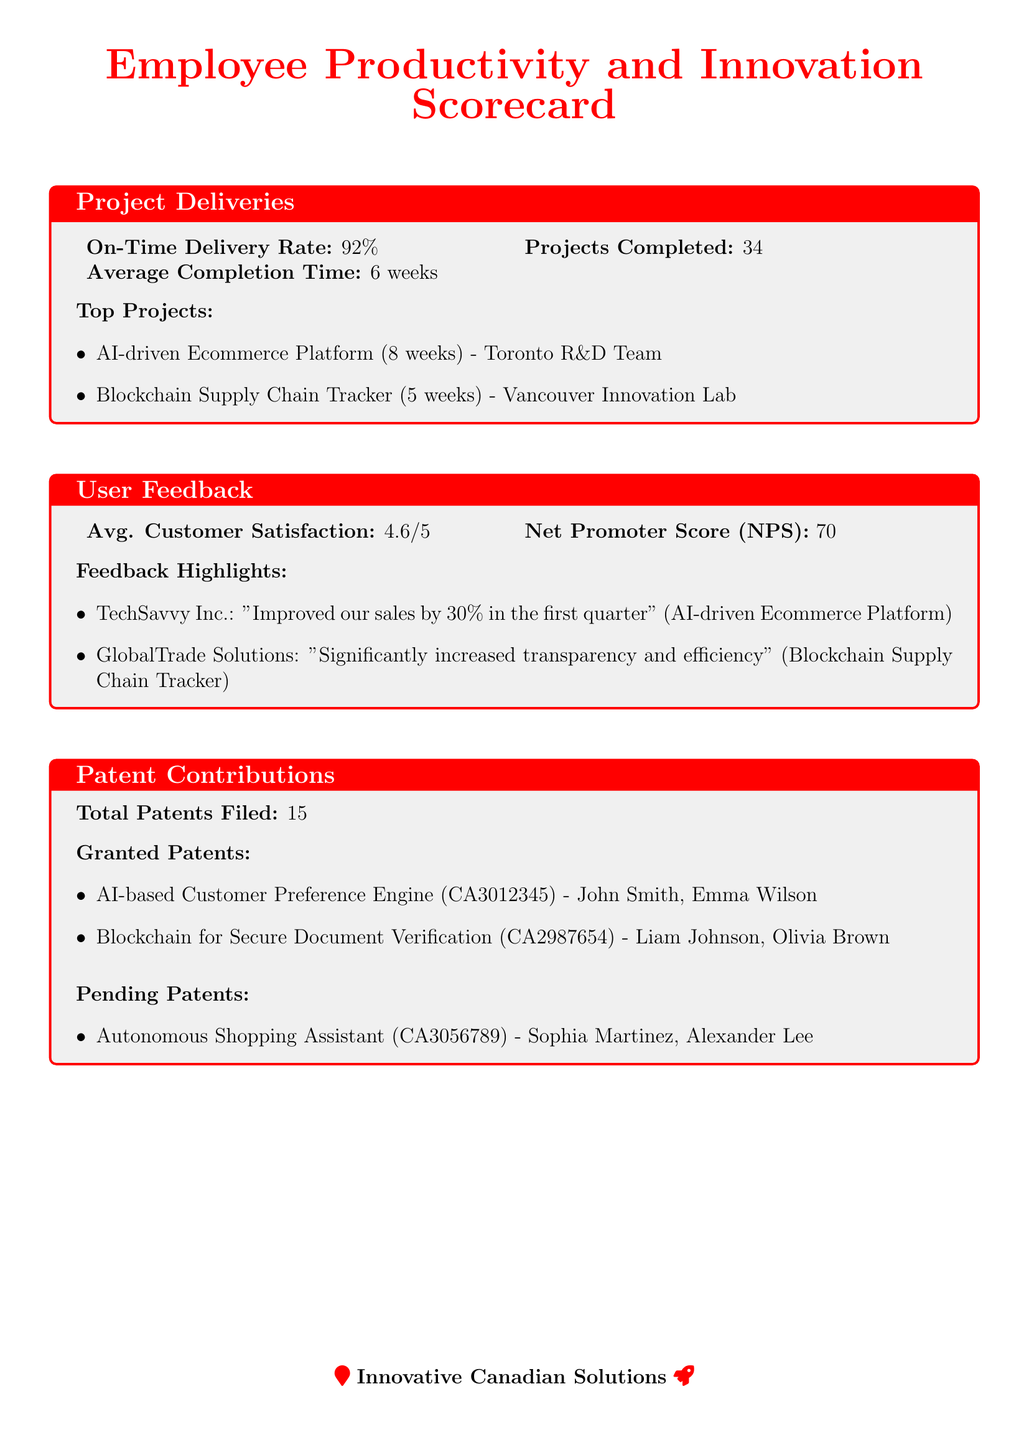What is the On-Time Delivery Rate? The On-Time Delivery Rate is a specific metric shown in the Project Deliveries section of the document, which states 92%.
Answer: 92% How many projects were completed? The document specifies a total of 34 projects completed in the Project Deliveries section.
Answer: 34 What is the Net Promoter Score (NPS)? The NPS is mentioned in the User Feedback section as a key metric, which is 70.
Answer: 70 Who are the inventors of the AI-based Customer Preference Engine? The document lists the inventors of this patent in the Patent Contributions section as John Smith and Emma Wilson.
Answer: John Smith, Emma Wilson What is the average customer satisfaction score? The average customer satisfaction score is reported in the User Feedback section, which is 4.6 out of 5.
Answer: 4.6/5 What is the average completion time for projects? The average completion time is a specific metric included in the Project Deliveries section and is noted as 6 weeks.
Answer: 6 weeks Which team completed the AI-driven Ecommerce Platform? This project is attributed to the Toronto R&D Team in the Project Deliveries section.
Answer: Toronto R&D Team How many patents are currently pending? The total number of pending patents is specified in the Patent Contributions section, which shows 1 pending patent.
Answer: 1 What project improved sales by 30% for TechSavvy Inc.? This information is found in the User Feedback section, specifically tied to the AI-driven Ecommerce Platform.
Answer: AI-driven Ecommerce Platform 